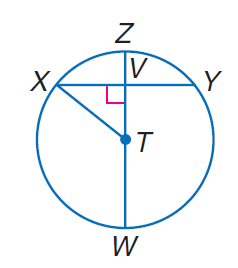Answer the mathemtical geometry problem and directly provide the correct option letter.
Question: In \odot T, Z V = 1, and T W = 13. Find X V.
Choices: A: 5 B: 11 C: 12 D: 13 A 